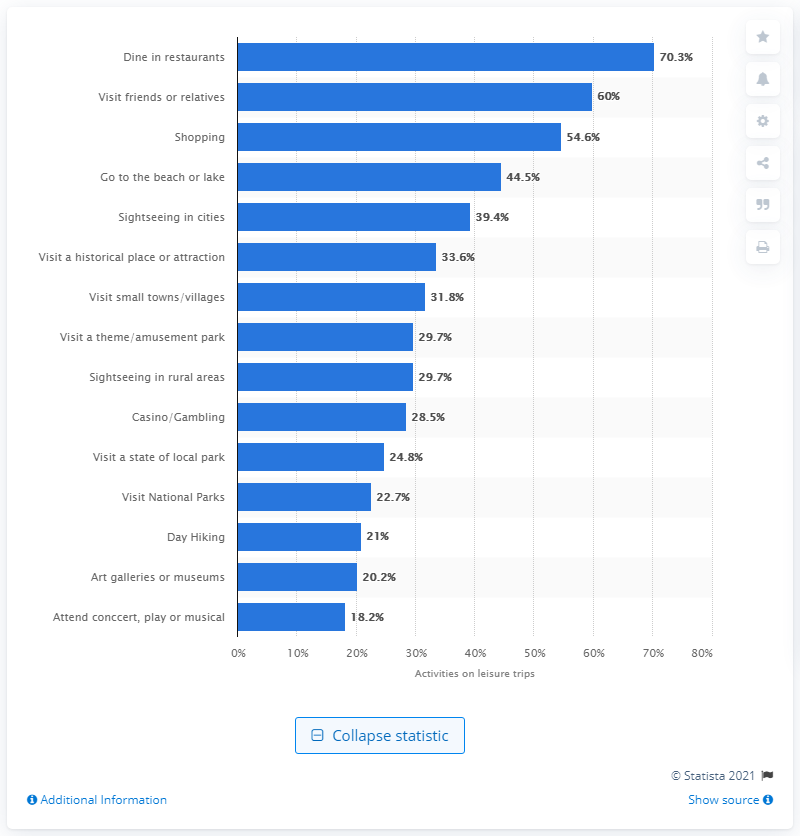Which activity is the second most popular among leisure trip travellers? Visiting friends or relatives is the second most popular activity, noted by 60% of leisure trip travellers according to the chart. 